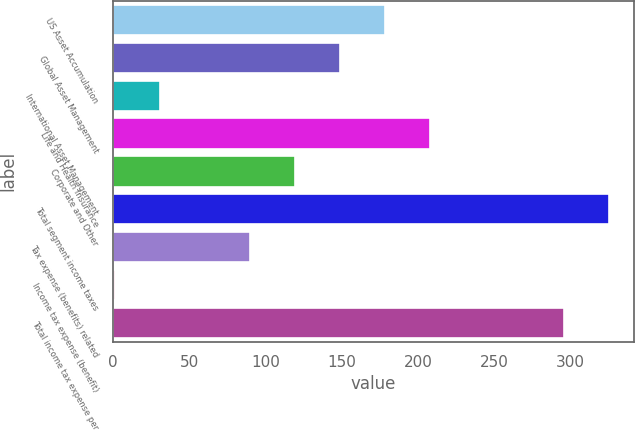Convert chart. <chart><loc_0><loc_0><loc_500><loc_500><bar_chart><fcel>US Asset Accumulation<fcel>Global Asset Management<fcel>International Asset Management<fcel>Life and Health Insurance<fcel>Corporate and Other<fcel>Total segment income taxes<fcel>Tax expense (benefits) related<fcel>Income tax expense (benefit)<fcel>Total income tax expense per<nl><fcel>178.4<fcel>148.85<fcel>30.65<fcel>207.95<fcel>119.3<fcel>325.45<fcel>89.75<fcel>1.1<fcel>295.9<nl></chart> 